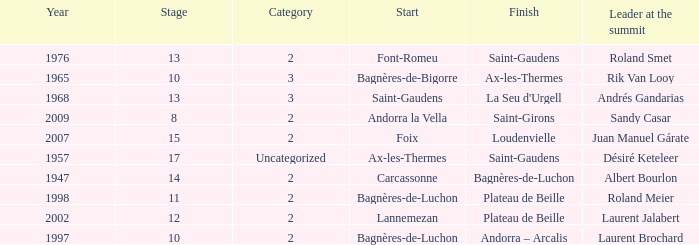Give the Finish for a Stage that is larger than 15 Saint-Gaudens. 